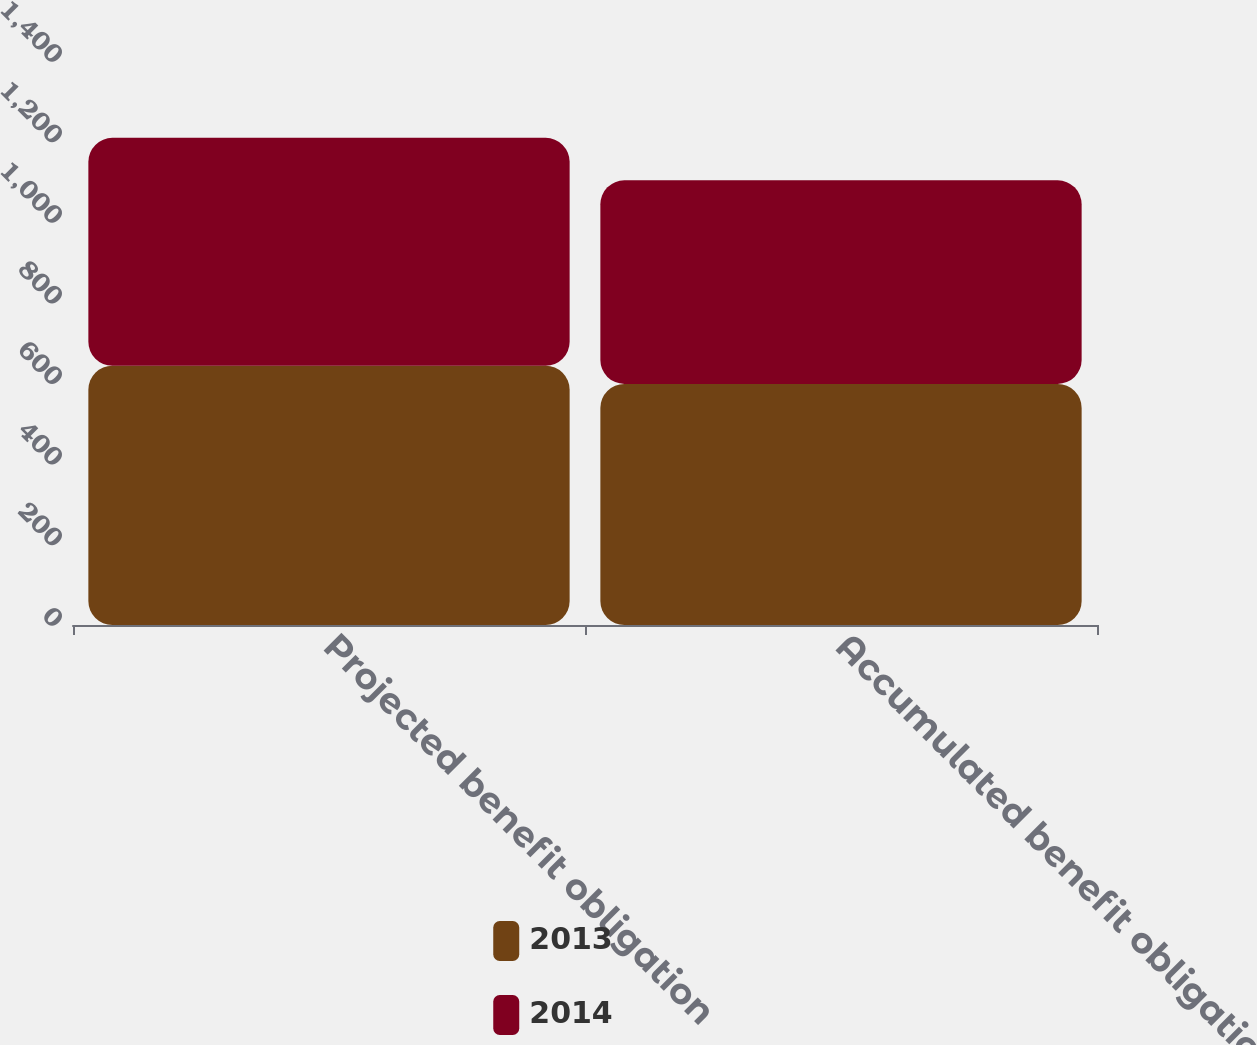<chart> <loc_0><loc_0><loc_500><loc_500><stacked_bar_chart><ecel><fcel>Projected benefit obligation<fcel>Accumulated benefit obligation<nl><fcel>2013<fcel>643.5<fcel>598.4<nl><fcel>2014<fcel>565.7<fcel>505.4<nl></chart> 